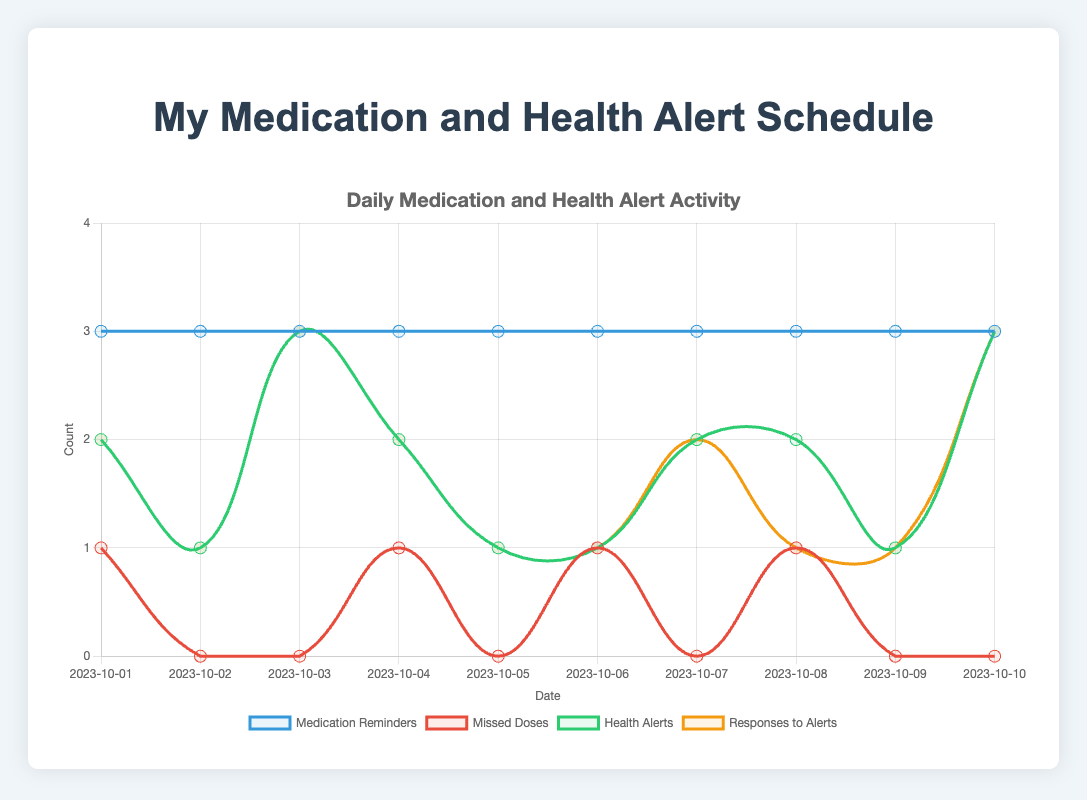How many days had no missed doses? To find the days with no missed doses, look for the days where the "Missed Doses" line touches the zero value on the y-axis. These days are 2023-10-02, 2023-10-03, 2023-10-05, 2023-10-07, 2023-10-09, and 2023-10-10. There are 6 such days.
Answer: 6 On which days did the responses to health alerts match the number of health alerts? Compare the "Health Alerts" and "Responses to Alerts" lines to find where they have the same count on the same day. This happens on 2023-10-01, 2023-10-02, 2023-10-03, 2023-10-04, 2023-10-05, 2023-10-06, 2023-10-07, 2023-10-09, and 2023-10-10.
Answer: 10/01, 10/02, 10/03, 10/04, 10/05, 10/06, 10/07, 10/09, 10/10 What is the total number of medication reminders over the 10 days? Add all the values of the "Medication Reminders" line. (3+3+3+3+3+3+3+3+3+3) = 30. The total number of medication reminders is 30.
Answer: 30 What is the highest number of health alerts recorded on any single day? Look at the peaks of the "Health Alerts" line. The highest value it touches is 3, which occurs on 2023-10-03 and 2023-10-10. Therefore, the highest number is 3.
Answer: 3 On which days do the lines for missed doses and health alerts intersect? Find where the "Missed Doses" and "Health Alerts" lines cross each other. This happens on 2023-10-01 and 2023-10-08.
Answer: 10/01 and 10/08 What is the average number of missed doses over the 10 days? Sum all values of "Missed Doses": (1+0+0+1+0+1+0+1+0+0) = 4. There are 10 days, so the average is 4/10 = 0.4.
Answer: 0.4 On which day did the number of responses to alerts fall short of the number of alerts? Look for where the "Responses to Alerts" line is below the "Health Alerts" line. This happens on 2023-10-08.
Answer: 10/08 Is there a correlation between the number of missed doses and responses to alerts? Visually inspect if high missed doses correlate with changes in responses to alerts. For instance, on days with missed doses (2023-10-01, 2023-10-04, 2023-10-06, 2023-10-08), responses to alerts don't seem drastically affected.
Answer: No clear correlation What's the average number of health alerts per day? Sum all values of "Health Alerts": (2+1+3+2+1+1+2+2+1+3) = 18. There are 10 days, so the average is 18/10 = 1.8.
Answer: 1.8 